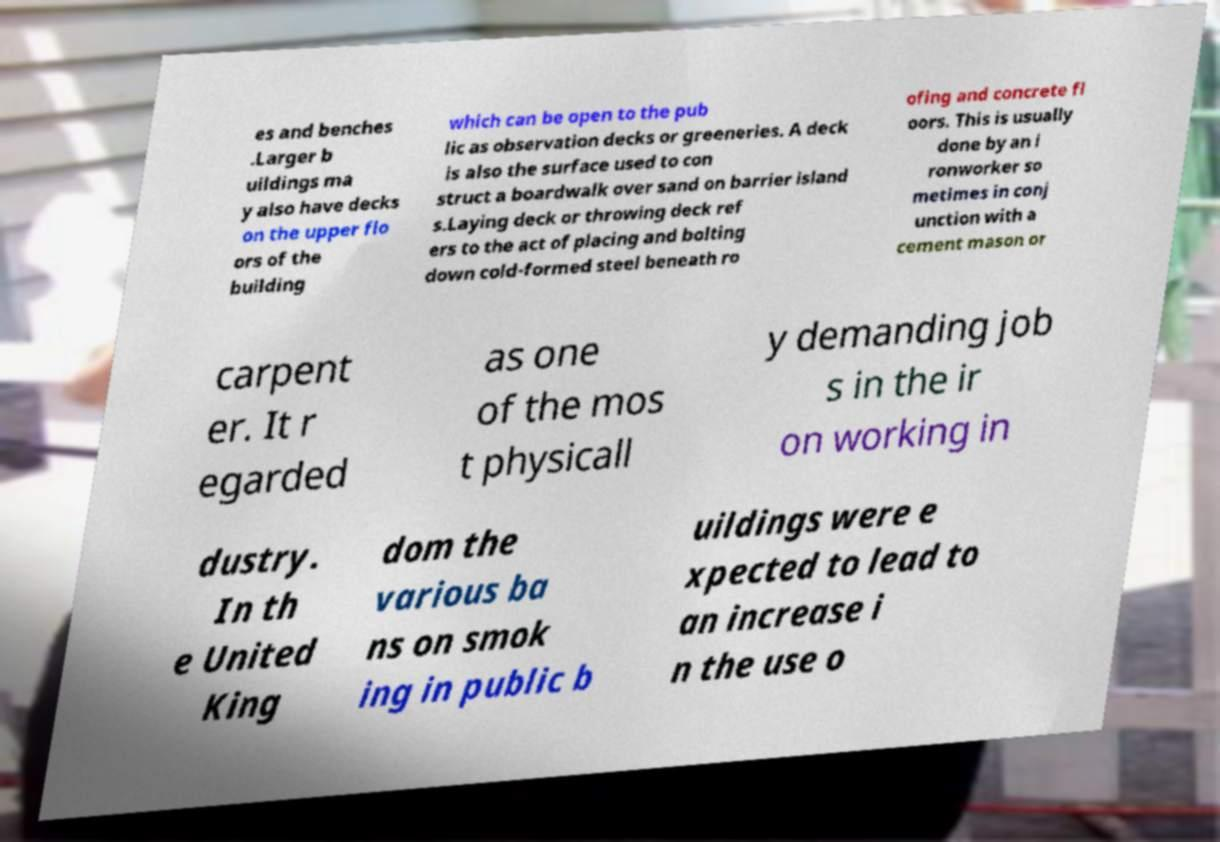Could you extract and type out the text from this image? es and benches .Larger b uildings ma y also have decks on the upper flo ors of the building which can be open to the pub lic as observation decks or greeneries. A deck is also the surface used to con struct a boardwalk over sand on barrier island s.Laying deck or throwing deck ref ers to the act of placing and bolting down cold-formed steel beneath ro ofing and concrete fl oors. This is usually done by an i ronworker so metimes in conj unction with a cement mason or carpent er. It r egarded as one of the mos t physicall y demanding job s in the ir on working in dustry. In th e United King dom the various ba ns on smok ing in public b uildings were e xpected to lead to an increase i n the use o 